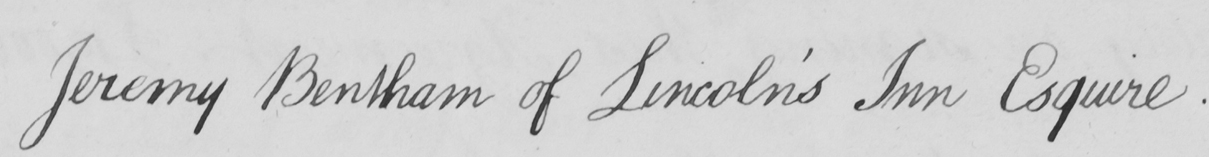What is written in this line of handwriting? Jeremy Bentham of Lincoln ' s Inn Esquire . 